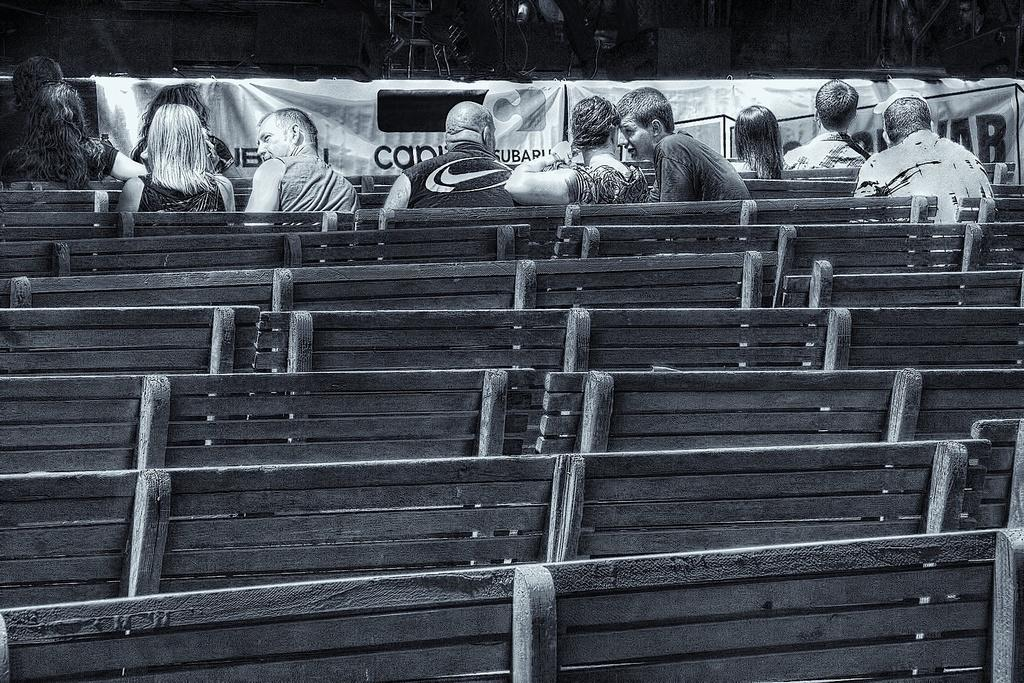How many people are in the image? There is a group of people in the image, but the exact number is not specified. What are the people doing in the image? The people are sitting on benches in the image. What can be seen in front of the people? There are banners and objects visible in front of the people. Can you see any pigs in the image? No, there are no pigs present in the image. What type of mountain is visible in the background of the image? There is no mountain visible in the image. 